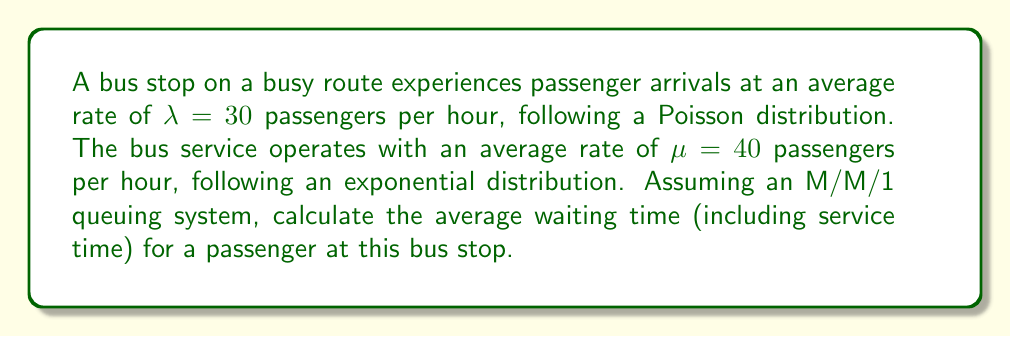What is the answer to this math problem? To solve this problem, we'll use the M/M/1 queuing model, which is appropriate for a single-server system with Poisson arrivals and exponential service times. Let's follow these steps:

1) First, calculate the utilization factor $\rho$:
   $$\rho = \frac{\lambda}{\mu} = \frac{30}{40} = 0.75$$

2) The average number of passengers in the system (including those being served) is given by:
   $$L = \frac{\rho}{1-\rho} = \frac{0.75}{1-0.75} = 3$$

3) Using Little's Law, we can calculate the average time a passenger spends in the system (including waiting and service time):
   $$W = \frac{L}{\lambda}$$

4) Substituting the values:
   $$W = \frac{3}{30} = 0.1 \text{ hours}$$

5) Convert the result to minutes:
   $$W = 0.1 \text{ hours} \times 60 \text{ minutes/hour} = 6 \text{ minutes}$$

Therefore, the average waiting time for a passenger at this bus stop, including service time, is 6 minutes.
Answer: 6 minutes 